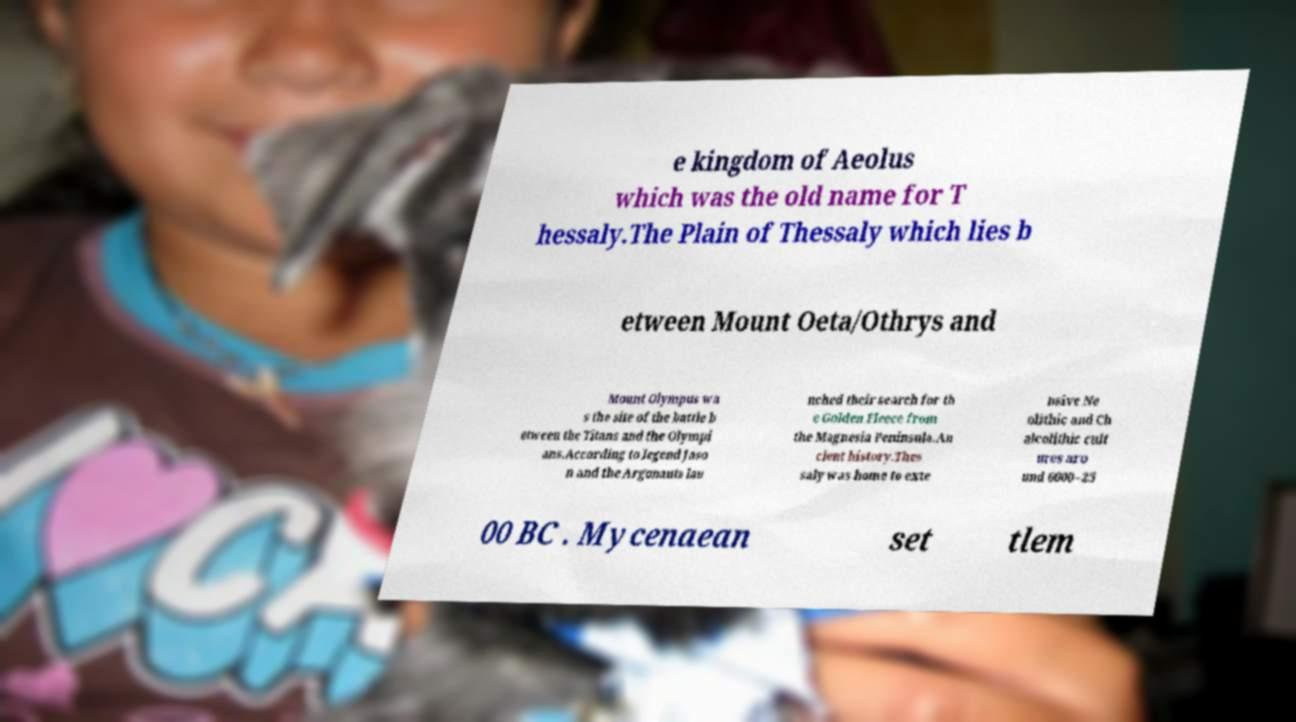Could you extract and type out the text from this image? e kingdom of Aeolus which was the old name for T hessaly.The Plain of Thessaly which lies b etween Mount Oeta/Othrys and Mount Olympus wa s the site of the battle b etween the Titans and the Olympi ans.According to legend Jaso n and the Argonauts lau nched their search for th e Golden Fleece from the Magnesia Peninsula.An cient history.Thes saly was home to exte nsive Ne olithic and Ch alcolithic cult ures aro und 6000–25 00 BC . Mycenaean set tlem 